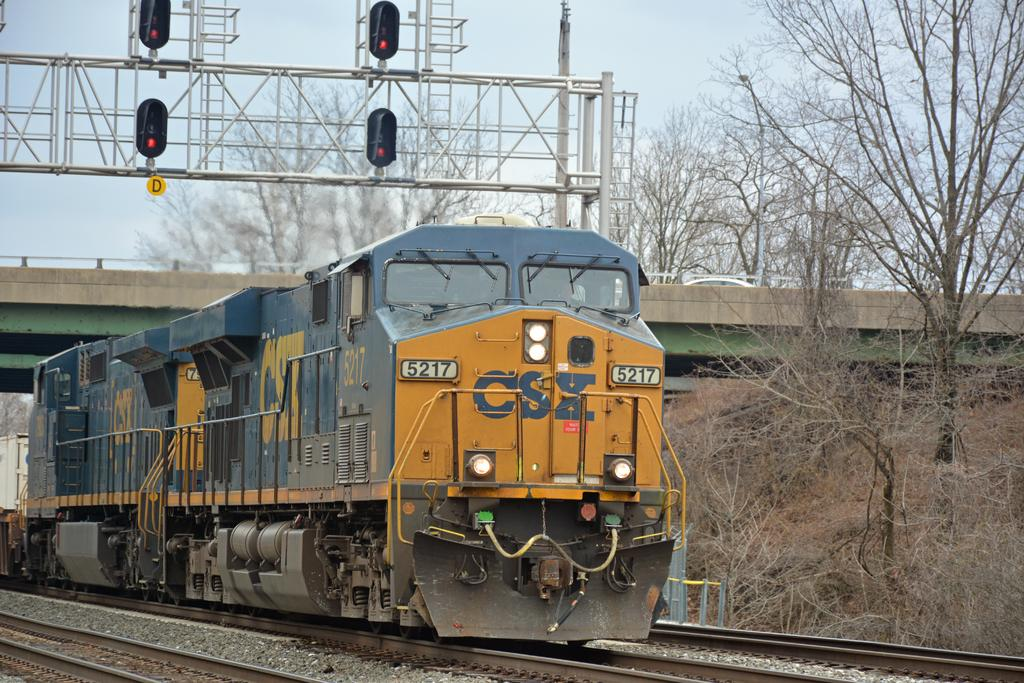What is the main subject of the image? The main subject of the image is an engine. What is the engine doing in the image? The engine is moving on a railway track. What color is the engine? The engine is blue in color. What safety feature is present on the engine? There are signal lights at the top of the engine. What can be seen on the right side of the image? There are trees on the right side of the image. What type of fork can be seen in the image? There is no fork present in the image; it features an engine moving on a railway track. Can you tell me where the picture is hanging in the image? There is no picture present in the image; it only shows an engine and its surroundings. 